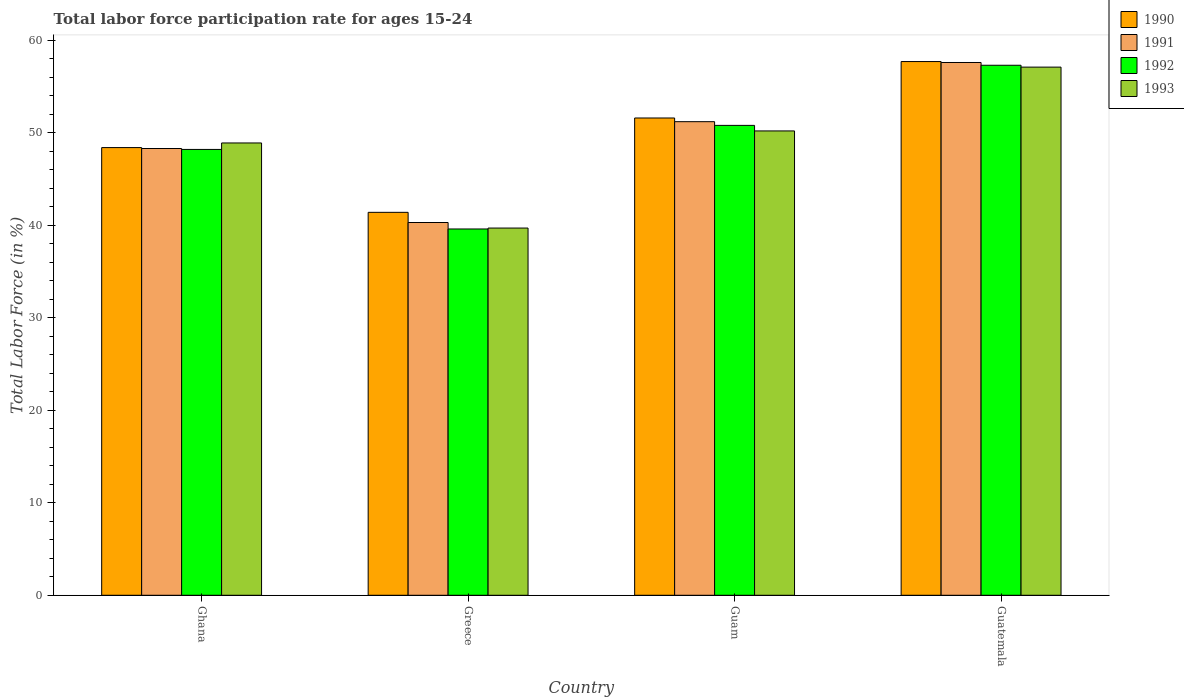How many groups of bars are there?
Provide a short and direct response. 4. Are the number of bars per tick equal to the number of legend labels?
Provide a short and direct response. Yes. How many bars are there on the 2nd tick from the right?
Your answer should be very brief. 4. What is the labor force participation rate in 1992 in Greece?
Offer a terse response. 39.6. Across all countries, what is the maximum labor force participation rate in 1990?
Ensure brevity in your answer.  57.7. Across all countries, what is the minimum labor force participation rate in 1992?
Keep it short and to the point. 39.6. In which country was the labor force participation rate in 1990 maximum?
Make the answer very short. Guatemala. What is the total labor force participation rate in 1990 in the graph?
Your response must be concise. 199.1. What is the difference between the labor force participation rate in 1991 in Ghana and that in Guam?
Your answer should be very brief. -2.9. What is the difference between the labor force participation rate in 1991 in Ghana and the labor force participation rate in 1992 in Guam?
Offer a terse response. -2.5. What is the average labor force participation rate in 1993 per country?
Offer a terse response. 48.98. What is the difference between the labor force participation rate of/in 1993 and labor force participation rate of/in 1991 in Greece?
Provide a short and direct response. -0.6. In how many countries, is the labor force participation rate in 1993 greater than 6 %?
Offer a very short reply. 4. What is the ratio of the labor force participation rate in 1992 in Guam to that in Guatemala?
Provide a succinct answer. 0.89. Is the labor force participation rate in 1990 in Greece less than that in Guam?
Your answer should be very brief. Yes. What is the difference between the highest and the second highest labor force participation rate in 1992?
Provide a short and direct response. -9.1. What is the difference between the highest and the lowest labor force participation rate in 1990?
Your answer should be compact. 16.3. In how many countries, is the labor force participation rate in 1990 greater than the average labor force participation rate in 1990 taken over all countries?
Keep it short and to the point. 2. Is the sum of the labor force participation rate in 1993 in Guam and Guatemala greater than the maximum labor force participation rate in 1990 across all countries?
Provide a succinct answer. Yes. What does the 4th bar from the left in Guam represents?
Your response must be concise. 1993. How many bars are there?
Provide a succinct answer. 16. Are all the bars in the graph horizontal?
Keep it short and to the point. No. How many countries are there in the graph?
Make the answer very short. 4. Does the graph contain any zero values?
Your response must be concise. No. Does the graph contain grids?
Ensure brevity in your answer.  No. Where does the legend appear in the graph?
Offer a terse response. Top right. What is the title of the graph?
Provide a succinct answer. Total labor force participation rate for ages 15-24. What is the label or title of the X-axis?
Provide a short and direct response. Country. What is the label or title of the Y-axis?
Ensure brevity in your answer.  Total Labor Force (in %). What is the Total Labor Force (in %) of 1990 in Ghana?
Your response must be concise. 48.4. What is the Total Labor Force (in %) in 1991 in Ghana?
Offer a very short reply. 48.3. What is the Total Labor Force (in %) in 1992 in Ghana?
Your answer should be compact. 48.2. What is the Total Labor Force (in %) in 1993 in Ghana?
Your answer should be very brief. 48.9. What is the Total Labor Force (in %) of 1990 in Greece?
Make the answer very short. 41.4. What is the Total Labor Force (in %) of 1991 in Greece?
Give a very brief answer. 40.3. What is the Total Labor Force (in %) of 1992 in Greece?
Ensure brevity in your answer.  39.6. What is the Total Labor Force (in %) of 1993 in Greece?
Ensure brevity in your answer.  39.7. What is the Total Labor Force (in %) of 1990 in Guam?
Provide a succinct answer. 51.6. What is the Total Labor Force (in %) in 1991 in Guam?
Give a very brief answer. 51.2. What is the Total Labor Force (in %) in 1992 in Guam?
Your answer should be compact. 50.8. What is the Total Labor Force (in %) in 1993 in Guam?
Your response must be concise. 50.2. What is the Total Labor Force (in %) in 1990 in Guatemala?
Provide a succinct answer. 57.7. What is the Total Labor Force (in %) in 1991 in Guatemala?
Offer a terse response. 57.6. What is the Total Labor Force (in %) of 1992 in Guatemala?
Give a very brief answer. 57.3. What is the Total Labor Force (in %) of 1993 in Guatemala?
Your response must be concise. 57.1. Across all countries, what is the maximum Total Labor Force (in %) of 1990?
Keep it short and to the point. 57.7. Across all countries, what is the maximum Total Labor Force (in %) of 1991?
Offer a very short reply. 57.6. Across all countries, what is the maximum Total Labor Force (in %) in 1992?
Provide a short and direct response. 57.3. Across all countries, what is the maximum Total Labor Force (in %) in 1993?
Provide a short and direct response. 57.1. Across all countries, what is the minimum Total Labor Force (in %) of 1990?
Your answer should be very brief. 41.4. Across all countries, what is the minimum Total Labor Force (in %) of 1991?
Make the answer very short. 40.3. Across all countries, what is the minimum Total Labor Force (in %) in 1992?
Ensure brevity in your answer.  39.6. Across all countries, what is the minimum Total Labor Force (in %) of 1993?
Provide a succinct answer. 39.7. What is the total Total Labor Force (in %) in 1990 in the graph?
Your response must be concise. 199.1. What is the total Total Labor Force (in %) of 1991 in the graph?
Keep it short and to the point. 197.4. What is the total Total Labor Force (in %) in 1992 in the graph?
Ensure brevity in your answer.  195.9. What is the total Total Labor Force (in %) of 1993 in the graph?
Ensure brevity in your answer.  195.9. What is the difference between the Total Labor Force (in %) in 1990 in Ghana and that in Greece?
Give a very brief answer. 7. What is the difference between the Total Labor Force (in %) of 1992 in Ghana and that in Greece?
Give a very brief answer. 8.6. What is the difference between the Total Labor Force (in %) of 1993 in Ghana and that in Greece?
Provide a short and direct response. 9.2. What is the difference between the Total Labor Force (in %) of 1991 in Ghana and that in Guam?
Make the answer very short. -2.9. What is the difference between the Total Labor Force (in %) of 1992 in Ghana and that in Guam?
Your answer should be compact. -2.6. What is the difference between the Total Labor Force (in %) of 1990 in Ghana and that in Guatemala?
Ensure brevity in your answer.  -9.3. What is the difference between the Total Labor Force (in %) of 1992 in Ghana and that in Guatemala?
Offer a terse response. -9.1. What is the difference between the Total Labor Force (in %) of 1991 in Greece and that in Guam?
Offer a very short reply. -10.9. What is the difference between the Total Labor Force (in %) in 1992 in Greece and that in Guam?
Your answer should be very brief. -11.2. What is the difference between the Total Labor Force (in %) of 1993 in Greece and that in Guam?
Your answer should be compact. -10.5. What is the difference between the Total Labor Force (in %) of 1990 in Greece and that in Guatemala?
Provide a succinct answer. -16.3. What is the difference between the Total Labor Force (in %) in 1991 in Greece and that in Guatemala?
Your response must be concise. -17.3. What is the difference between the Total Labor Force (in %) of 1992 in Greece and that in Guatemala?
Make the answer very short. -17.7. What is the difference between the Total Labor Force (in %) in 1993 in Greece and that in Guatemala?
Provide a short and direct response. -17.4. What is the difference between the Total Labor Force (in %) in 1991 in Guam and that in Guatemala?
Your response must be concise. -6.4. What is the difference between the Total Labor Force (in %) in 1990 in Ghana and the Total Labor Force (in %) in 1992 in Greece?
Your response must be concise. 8.8. What is the difference between the Total Labor Force (in %) of 1990 in Ghana and the Total Labor Force (in %) of 1993 in Greece?
Offer a very short reply. 8.7. What is the difference between the Total Labor Force (in %) of 1991 in Ghana and the Total Labor Force (in %) of 1992 in Greece?
Your answer should be compact. 8.7. What is the difference between the Total Labor Force (in %) of 1990 in Ghana and the Total Labor Force (in %) of 1991 in Guam?
Ensure brevity in your answer.  -2.8. What is the difference between the Total Labor Force (in %) in 1990 in Ghana and the Total Labor Force (in %) in 1992 in Guam?
Provide a succinct answer. -2.4. What is the difference between the Total Labor Force (in %) in 1990 in Ghana and the Total Labor Force (in %) in 1993 in Guam?
Provide a succinct answer. -1.8. What is the difference between the Total Labor Force (in %) in 1991 in Ghana and the Total Labor Force (in %) in 1993 in Guam?
Your answer should be very brief. -1.9. What is the difference between the Total Labor Force (in %) in 1990 in Ghana and the Total Labor Force (in %) in 1991 in Guatemala?
Ensure brevity in your answer.  -9.2. What is the difference between the Total Labor Force (in %) in 1990 in Ghana and the Total Labor Force (in %) in 1992 in Guatemala?
Offer a terse response. -8.9. What is the difference between the Total Labor Force (in %) of 1991 in Ghana and the Total Labor Force (in %) of 1992 in Guatemala?
Keep it short and to the point. -9. What is the difference between the Total Labor Force (in %) of 1991 in Ghana and the Total Labor Force (in %) of 1993 in Guatemala?
Make the answer very short. -8.8. What is the difference between the Total Labor Force (in %) of 1992 in Ghana and the Total Labor Force (in %) of 1993 in Guatemala?
Provide a short and direct response. -8.9. What is the difference between the Total Labor Force (in %) of 1990 in Greece and the Total Labor Force (in %) of 1992 in Guam?
Provide a short and direct response. -9.4. What is the difference between the Total Labor Force (in %) in 1990 in Greece and the Total Labor Force (in %) in 1993 in Guam?
Ensure brevity in your answer.  -8.8. What is the difference between the Total Labor Force (in %) of 1990 in Greece and the Total Labor Force (in %) of 1991 in Guatemala?
Give a very brief answer. -16.2. What is the difference between the Total Labor Force (in %) in 1990 in Greece and the Total Labor Force (in %) in 1992 in Guatemala?
Keep it short and to the point. -15.9. What is the difference between the Total Labor Force (in %) of 1990 in Greece and the Total Labor Force (in %) of 1993 in Guatemala?
Provide a short and direct response. -15.7. What is the difference between the Total Labor Force (in %) in 1991 in Greece and the Total Labor Force (in %) in 1993 in Guatemala?
Provide a succinct answer. -16.8. What is the difference between the Total Labor Force (in %) of 1992 in Greece and the Total Labor Force (in %) of 1993 in Guatemala?
Provide a short and direct response. -17.5. What is the difference between the Total Labor Force (in %) of 1990 in Guam and the Total Labor Force (in %) of 1991 in Guatemala?
Give a very brief answer. -6. What is the difference between the Total Labor Force (in %) of 1991 in Guam and the Total Labor Force (in %) of 1992 in Guatemala?
Make the answer very short. -6.1. What is the difference between the Total Labor Force (in %) in 1992 in Guam and the Total Labor Force (in %) in 1993 in Guatemala?
Give a very brief answer. -6.3. What is the average Total Labor Force (in %) of 1990 per country?
Provide a succinct answer. 49.77. What is the average Total Labor Force (in %) in 1991 per country?
Your response must be concise. 49.35. What is the average Total Labor Force (in %) of 1992 per country?
Give a very brief answer. 48.98. What is the average Total Labor Force (in %) of 1993 per country?
Make the answer very short. 48.98. What is the difference between the Total Labor Force (in %) in 1990 and Total Labor Force (in %) in 1992 in Ghana?
Provide a succinct answer. 0.2. What is the difference between the Total Labor Force (in %) in 1990 and Total Labor Force (in %) in 1991 in Greece?
Give a very brief answer. 1.1. What is the difference between the Total Labor Force (in %) of 1991 and Total Labor Force (in %) of 1992 in Greece?
Offer a terse response. 0.7. What is the difference between the Total Labor Force (in %) in 1990 and Total Labor Force (in %) in 1992 in Guam?
Offer a very short reply. 0.8. What is the difference between the Total Labor Force (in %) in 1990 and Total Labor Force (in %) in 1993 in Guam?
Ensure brevity in your answer.  1.4. What is the difference between the Total Labor Force (in %) in 1990 and Total Labor Force (in %) in 1991 in Guatemala?
Your answer should be very brief. 0.1. What is the difference between the Total Labor Force (in %) of 1992 and Total Labor Force (in %) of 1993 in Guatemala?
Provide a short and direct response. 0.2. What is the ratio of the Total Labor Force (in %) of 1990 in Ghana to that in Greece?
Offer a terse response. 1.17. What is the ratio of the Total Labor Force (in %) in 1991 in Ghana to that in Greece?
Provide a succinct answer. 1.2. What is the ratio of the Total Labor Force (in %) in 1992 in Ghana to that in Greece?
Offer a very short reply. 1.22. What is the ratio of the Total Labor Force (in %) of 1993 in Ghana to that in Greece?
Provide a short and direct response. 1.23. What is the ratio of the Total Labor Force (in %) of 1990 in Ghana to that in Guam?
Your response must be concise. 0.94. What is the ratio of the Total Labor Force (in %) in 1991 in Ghana to that in Guam?
Your response must be concise. 0.94. What is the ratio of the Total Labor Force (in %) of 1992 in Ghana to that in Guam?
Your response must be concise. 0.95. What is the ratio of the Total Labor Force (in %) of 1993 in Ghana to that in Guam?
Keep it short and to the point. 0.97. What is the ratio of the Total Labor Force (in %) in 1990 in Ghana to that in Guatemala?
Make the answer very short. 0.84. What is the ratio of the Total Labor Force (in %) of 1991 in Ghana to that in Guatemala?
Provide a short and direct response. 0.84. What is the ratio of the Total Labor Force (in %) in 1992 in Ghana to that in Guatemala?
Your answer should be compact. 0.84. What is the ratio of the Total Labor Force (in %) in 1993 in Ghana to that in Guatemala?
Offer a terse response. 0.86. What is the ratio of the Total Labor Force (in %) of 1990 in Greece to that in Guam?
Your answer should be very brief. 0.8. What is the ratio of the Total Labor Force (in %) of 1991 in Greece to that in Guam?
Provide a succinct answer. 0.79. What is the ratio of the Total Labor Force (in %) in 1992 in Greece to that in Guam?
Provide a succinct answer. 0.78. What is the ratio of the Total Labor Force (in %) in 1993 in Greece to that in Guam?
Keep it short and to the point. 0.79. What is the ratio of the Total Labor Force (in %) of 1990 in Greece to that in Guatemala?
Your answer should be very brief. 0.72. What is the ratio of the Total Labor Force (in %) of 1991 in Greece to that in Guatemala?
Offer a very short reply. 0.7. What is the ratio of the Total Labor Force (in %) in 1992 in Greece to that in Guatemala?
Offer a very short reply. 0.69. What is the ratio of the Total Labor Force (in %) of 1993 in Greece to that in Guatemala?
Ensure brevity in your answer.  0.7. What is the ratio of the Total Labor Force (in %) of 1990 in Guam to that in Guatemala?
Your answer should be very brief. 0.89. What is the ratio of the Total Labor Force (in %) of 1991 in Guam to that in Guatemala?
Offer a very short reply. 0.89. What is the ratio of the Total Labor Force (in %) of 1992 in Guam to that in Guatemala?
Give a very brief answer. 0.89. What is the ratio of the Total Labor Force (in %) of 1993 in Guam to that in Guatemala?
Provide a succinct answer. 0.88. What is the difference between the highest and the second highest Total Labor Force (in %) of 1990?
Your response must be concise. 6.1. What is the difference between the highest and the lowest Total Labor Force (in %) in 1990?
Give a very brief answer. 16.3. What is the difference between the highest and the lowest Total Labor Force (in %) in 1991?
Your answer should be compact. 17.3. What is the difference between the highest and the lowest Total Labor Force (in %) of 1993?
Keep it short and to the point. 17.4. 